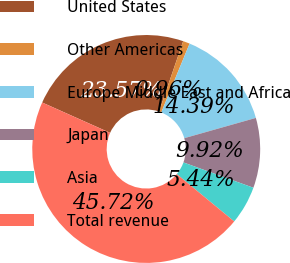Convert chart to OTSL. <chart><loc_0><loc_0><loc_500><loc_500><pie_chart><fcel>United States<fcel>Other Americas<fcel>Europe Middle East and Africa<fcel>Japan<fcel>Asia<fcel>Total revenue<nl><fcel>23.57%<fcel>0.96%<fcel>14.39%<fcel>9.92%<fcel>5.44%<fcel>45.72%<nl></chart> 